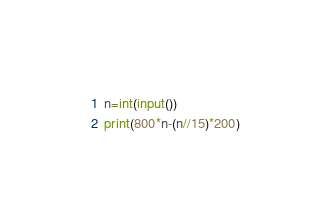Convert code to text. <code><loc_0><loc_0><loc_500><loc_500><_Python_>n=int(input())
print(800*n-(n//15)*200)</code> 